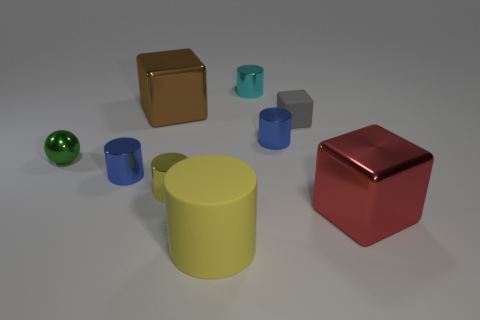Is the material of the tiny gray object the same as the green sphere?
Provide a succinct answer. No. The metal ball that is the same size as the gray rubber cube is what color?
Your response must be concise. Green. The cube that is on the right side of the brown cube and behind the red block is what color?
Provide a short and direct response. Gray. There is a yellow cylinder in front of the large metallic thing that is to the right of the large shiny object to the left of the tiny yellow thing; how big is it?
Provide a succinct answer. Large. What is the material of the green ball?
Offer a very short reply. Metal. Is the large yellow thing made of the same material as the large block behind the green ball?
Your response must be concise. No. Is there anything else of the same color as the big rubber object?
Make the answer very short. Yes. Are there any tiny yellow metallic cylinders that are to the left of the big shiny block that is behind the big red metallic block in front of the green metal thing?
Give a very brief answer. No. The ball is what color?
Ensure brevity in your answer.  Green. There is a red object; are there any cylinders in front of it?
Offer a terse response. Yes. 